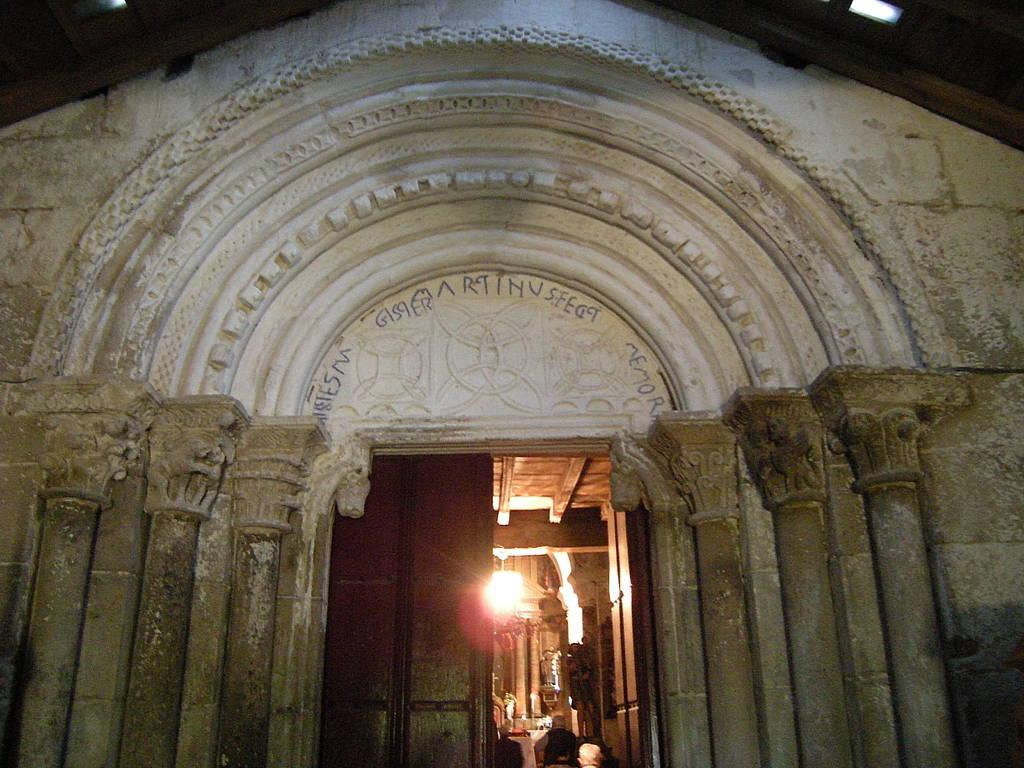What type of structure is visible in the image? There is a building in the image. Who or what can be seen in the image besides the building? There are people visible in the image. What can be seen illuminating the scene in the image? There are lights visible in the image. What architectural feature is present in the image? There are pillars in the image. Can you describe any other objects present in the image? There are other objects present in the image, but their specific details are not mentioned in the provided facts. What type of pets are visible in the image? There are no pets visible in the image. 